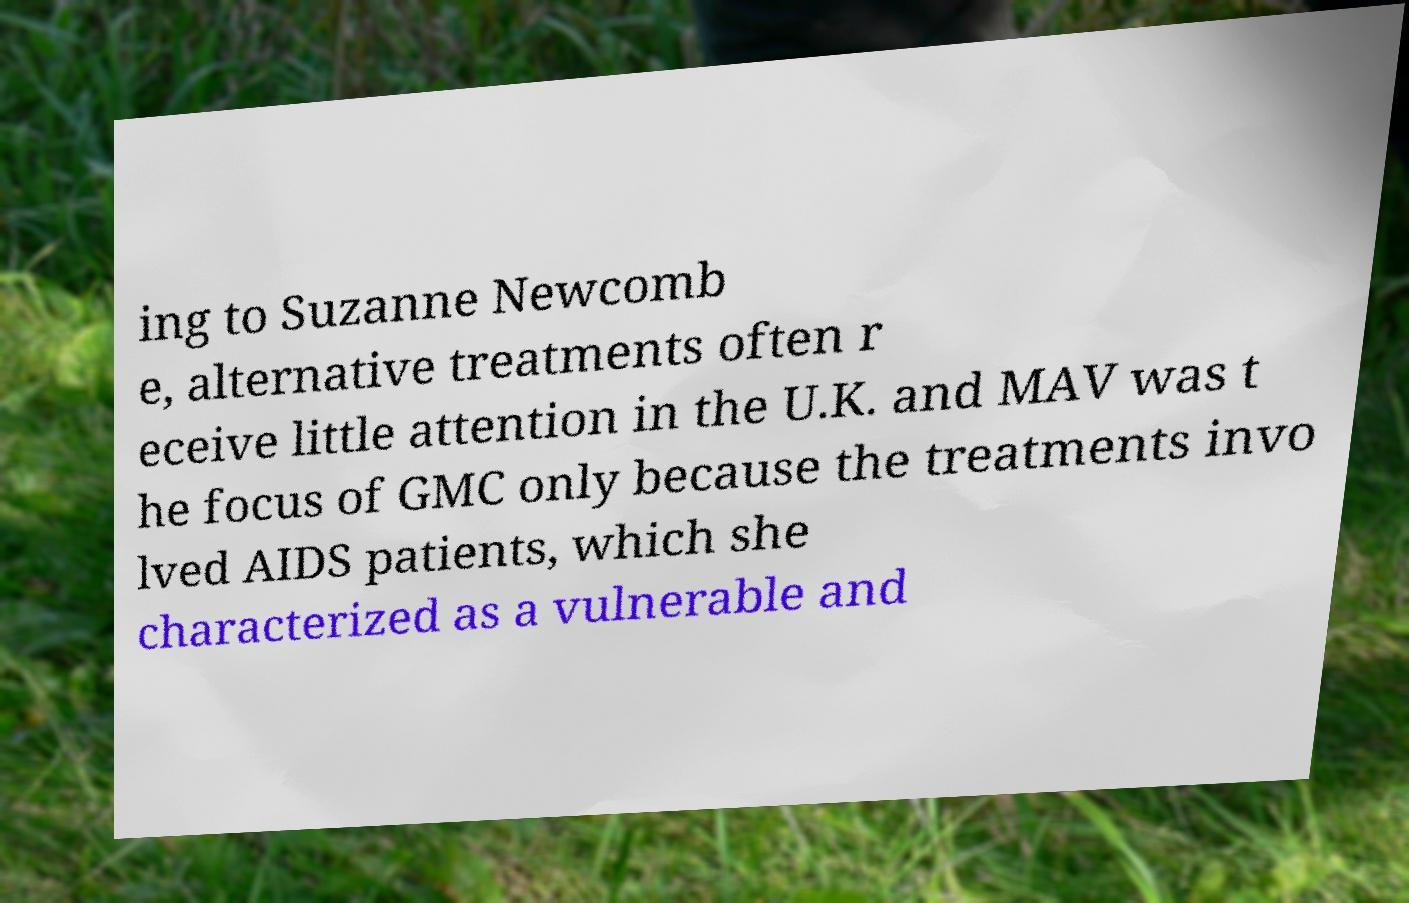Can you read and provide the text displayed in the image?This photo seems to have some interesting text. Can you extract and type it out for me? ing to Suzanne Newcomb e, alternative treatments often r eceive little attention in the U.K. and MAV was t he focus of GMC only because the treatments invo lved AIDS patients, which she characterized as a vulnerable and 